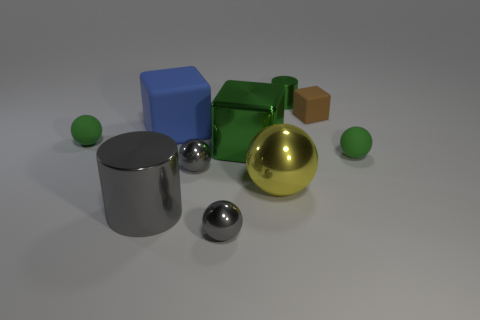Subtract all gray cylinders. How many cylinders are left? 1 Subtract all gray metal balls. How many balls are left? 3 Subtract all cylinders. How many objects are left? 8 Subtract 2 cylinders. How many cylinders are left? 0 Subtract 1 green balls. How many objects are left? 9 Subtract all blue spheres. Subtract all red cylinders. How many spheres are left? 5 Subtract all green blocks. How many blue cylinders are left? 0 Subtract all matte blocks. Subtract all metallic blocks. How many objects are left? 7 Add 5 tiny brown things. How many tiny brown things are left? 6 Add 7 large yellow objects. How many large yellow objects exist? 8 